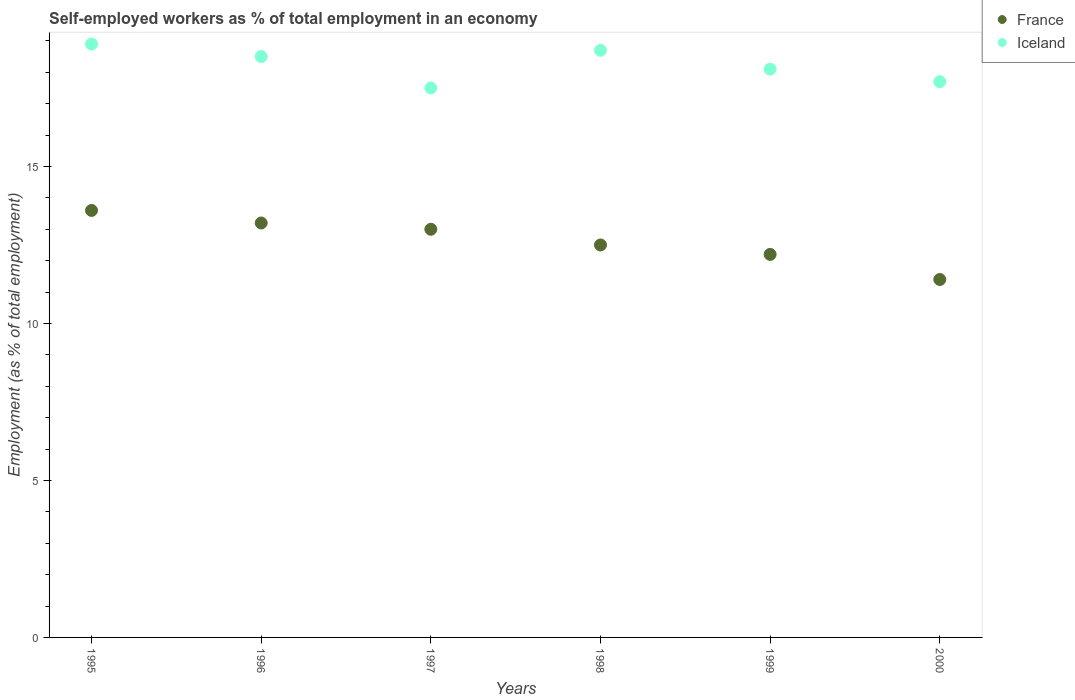Is the number of dotlines equal to the number of legend labels?
Your answer should be compact. Yes. What is the percentage of self-employed workers in Iceland in 1996?
Keep it short and to the point. 18.5. Across all years, what is the maximum percentage of self-employed workers in France?
Your answer should be compact. 13.6. In which year was the percentage of self-employed workers in France maximum?
Ensure brevity in your answer.  1995. What is the total percentage of self-employed workers in Iceland in the graph?
Offer a very short reply. 109.4. What is the difference between the percentage of self-employed workers in Iceland in 1995 and that in 1999?
Provide a short and direct response. 0.8. What is the difference between the percentage of self-employed workers in Iceland in 2000 and the percentage of self-employed workers in France in 1996?
Offer a very short reply. 4.5. What is the average percentage of self-employed workers in Iceland per year?
Your answer should be compact. 18.23. In the year 2000, what is the difference between the percentage of self-employed workers in Iceland and percentage of self-employed workers in France?
Offer a terse response. 6.3. In how many years, is the percentage of self-employed workers in France greater than 11 %?
Your response must be concise. 6. What is the ratio of the percentage of self-employed workers in Iceland in 1998 to that in 2000?
Your answer should be very brief. 1.06. Is the percentage of self-employed workers in Iceland in 1996 less than that in 2000?
Offer a very short reply. No. What is the difference between the highest and the second highest percentage of self-employed workers in Iceland?
Give a very brief answer. 0.2. What is the difference between the highest and the lowest percentage of self-employed workers in Iceland?
Your answer should be compact. 1.4. In how many years, is the percentage of self-employed workers in Iceland greater than the average percentage of self-employed workers in Iceland taken over all years?
Offer a terse response. 3. Is the percentage of self-employed workers in Iceland strictly greater than the percentage of self-employed workers in France over the years?
Your answer should be very brief. Yes. Is the percentage of self-employed workers in Iceland strictly less than the percentage of self-employed workers in France over the years?
Keep it short and to the point. No. How many dotlines are there?
Give a very brief answer. 2. How many years are there in the graph?
Provide a succinct answer. 6. What is the difference between two consecutive major ticks on the Y-axis?
Your answer should be very brief. 5. Are the values on the major ticks of Y-axis written in scientific E-notation?
Keep it short and to the point. No. Where does the legend appear in the graph?
Your answer should be compact. Top right. How many legend labels are there?
Your response must be concise. 2. How are the legend labels stacked?
Ensure brevity in your answer.  Vertical. What is the title of the graph?
Keep it short and to the point. Self-employed workers as % of total employment in an economy. What is the label or title of the Y-axis?
Keep it short and to the point. Employment (as % of total employment). What is the Employment (as % of total employment) in France in 1995?
Make the answer very short. 13.6. What is the Employment (as % of total employment) in Iceland in 1995?
Provide a succinct answer. 18.9. What is the Employment (as % of total employment) of France in 1996?
Ensure brevity in your answer.  13.2. What is the Employment (as % of total employment) of Iceland in 1996?
Provide a short and direct response. 18.5. What is the Employment (as % of total employment) of France in 1997?
Ensure brevity in your answer.  13. What is the Employment (as % of total employment) in Iceland in 1997?
Ensure brevity in your answer.  17.5. What is the Employment (as % of total employment) in France in 1998?
Provide a succinct answer. 12.5. What is the Employment (as % of total employment) of Iceland in 1998?
Your answer should be very brief. 18.7. What is the Employment (as % of total employment) of France in 1999?
Your answer should be very brief. 12.2. What is the Employment (as % of total employment) in Iceland in 1999?
Keep it short and to the point. 18.1. What is the Employment (as % of total employment) of France in 2000?
Your answer should be compact. 11.4. What is the Employment (as % of total employment) of Iceland in 2000?
Your answer should be very brief. 17.7. Across all years, what is the maximum Employment (as % of total employment) in France?
Your answer should be very brief. 13.6. Across all years, what is the maximum Employment (as % of total employment) of Iceland?
Make the answer very short. 18.9. Across all years, what is the minimum Employment (as % of total employment) in France?
Offer a very short reply. 11.4. What is the total Employment (as % of total employment) in France in the graph?
Give a very brief answer. 75.9. What is the total Employment (as % of total employment) in Iceland in the graph?
Your response must be concise. 109.4. What is the difference between the Employment (as % of total employment) of France in 1995 and that in 1996?
Provide a short and direct response. 0.4. What is the difference between the Employment (as % of total employment) of France in 1995 and that in 1997?
Your answer should be very brief. 0.6. What is the difference between the Employment (as % of total employment) in Iceland in 1995 and that in 1998?
Your answer should be compact. 0.2. What is the difference between the Employment (as % of total employment) of France in 1995 and that in 1999?
Give a very brief answer. 1.4. What is the difference between the Employment (as % of total employment) in Iceland in 1995 and that in 1999?
Your response must be concise. 0.8. What is the difference between the Employment (as % of total employment) in France in 1996 and that in 1999?
Provide a short and direct response. 1. What is the difference between the Employment (as % of total employment) of France in 1996 and that in 2000?
Your response must be concise. 1.8. What is the difference between the Employment (as % of total employment) of Iceland in 1996 and that in 2000?
Your answer should be very brief. 0.8. What is the difference between the Employment (as % of total employment) of France in 1997 and that in 1998?
Offer a terse response. 0.5. What is the difference between the Employment (as % of total employment) of Iceland in 1997 and that in 1998?
Offer a very short reply. -1.2. What is the difference between the Employment (as % of total employment) of France in 1997 and that in 1999?
Your answer should be compact. 0.8. What is the difference between the Employment (as % of total employment) of France in 1998 and that in 1999?
Offer a terse response. 0.3. What is the difference between the Employment (as % of total employment) in France in 1998 and that in 2000?
Your response must be concise. 1.1. What is the difference between the Employment (as % of total employment) of Iceland in 1999 and that in 2000?
Make the answer very short. 0.4. What is the difference between the Employment (as % of total employment) in France in 1995 and the Employment (as % of total employment) in Iceland in 1997?
Offer a very short reply. -3.9. What is the difference between the Employment (as % of total employment) in France in 1995 and the Employment (as % of total employment) in Iceland in 1999?
Offer a terse response. -4.5. What is the difference between the Employment (as % of total employment) in France in 1996 and the Employment (as % of total employment) in Iceland in 1997?
Make the answer very short. -4.3. What is the difference between the Employment (as % of total employment) of France in 1996 and the Employment (as % of total employment) of Iceland in 1999?
Offer a terse response. -4.9. What is the difference between the Employment (as % of total employment) of France in 1996 and the Employment (as % of total employment) of Iceland in 2000?
Your answer should be compact. -4.5. What is the difference between the Employment (as % of total employment) in France in 1997 and the Employment (as % of total employment) in Iceland in 1999?
Make the answer very short. -5.1. What is the difference between the Employment (as % of total employment) in France in 1997 and the Employment (as % of total employment) in Iceland in 2000?
Keep it short and to the point. -4.7. What is the difference between the Employment (as % of total employment) in France in 1998 and the Employment (as % of total employment) in Iceland in 2000?
Offer a terse response. -5.2. What is the average Employment (as % of total employment) in France per year?
Make the answer very short. 12.65. What is the average Employment (as % of total employment) in Iceland per year?
Keep it short and to the point. 18.23. In the year 1998, what is the difference between the Employment (as % of total employment) of France and Employment (as % of total employment) of Iceland?
Provide a succinct answer. -6.2. In the year 1999, what is the difference between the Employment (as % of total employment) of France and Employment (as % of total employment) of Iceland?
Your response must be concise. -5.9. In the year 2000, what is the difference between the Employment (as % of total employment) of France and Employment (as % of total employment) of Iceland?
Make the answer very short. -6.3. What is the ratio of the Employment (as % of total employment) in France in 1995 to that in 1996?
Provide a short and direct response. 1.03. What is the ratio of the Employment (as % of total employment) in Iceland in 1995 to that in 1996?
Provide a short and direct response. 1.02. What is the ratio of the Employment (as % of total employment) of France in 1995 to that in 1997?
Ensure brevity in your answer.  1.05. What is the ratio of the Employment (as % of total employment) in Iceland in 1995 to that in 1997?
Your answer should be very brief. 1.08. What is the ratio of the Employment (as % of total employment) in France in 1995 to that in 1998?
Ensure brevity in your answer.  1.09. What is the ratio of the Employment (as % of total employment) of Iceland in 1995 to that in 1998?
Provide a succinct answer. 1.01. What is the ratio of the Employment (as % of total employment) in France in 1995 to that in 1999?
Provide a succinct answer. 1.11. What is the ratio of the Employment (as % of total employment) of Iceland in 1995 to that in 1999?
Your answer should be very brief. 1.04. What is the ratio of the Employment (as % of total employment) in France in 1995 to that in 2000?
Your response must be concise. 1.19. What is the ratio of the Employment (as % of total employment) in Iceland in 1995 to that in 2000?
Your answer should be compact. 1.07. What is the ratio of the Employment (as % of total employment) in France in 1996 to that in 1997?
Offer a terse response. 1.02. What is the ratio of the Employment (as % of total employment) in Iceland in 1996 to that in 1997?
Keep it short and to the point. 1.06. What is the ratio of the Employment (as % of total employment) of France in 1996 to that in 1998?
Ensure brevity in your answer.  1.06. What is the ratio of the Employment (as % of total employment) of Iceland in 1996 to that in 1998?
Your answer should be very brief. 0.99. What is the ratio of the Employment (as % of total employment) of France in 1996 to that in 1999?
Offer a terse response. 1.08. What is the ratio of the Employment (as % of total employment) of Iceland in 1996 to that in 1999?
Make the answer very short. 1.02. What is the ratio of the Employment (as % of total employment) of France in 1996 to that in 2000?
Keep it short and to the point. 1.16. What is the ratio of the Employment (as % of total employment) in Iceland in 1996 to that in 2000?
Your response must be concise. 1.05. What is the ratio of the Employment (as % of total employment) of Iceland in 1997 to that in 1998?
Provide a succinct answer. 0.94. What is the ratio of the Employment (as % of total employment) in France in 1997 to that in 1999?
Give a very brief answer. 1.07. What is the ratio of the Employment (as % of total employment) of Iceland in 1997 to that in 1999?
Your response must be concise. 0.97. What is the ratio of the Employment (as % of total employment) in France in 1997 to that in 2000?
Your answer should be compact. 1.14. What is the ratio of the Employment (as % of total employment) in Iceland in 1997 to that in 2000?
Keep it short and to the point. 0.99. What is the ratio of the Employment (as % of total employment) of France in 1998 to that in 1999?
Offer a very short reply. 1.02. What is the ratio of the Employment (as % of total employment) of Iceland in 1998 to that in 1999?
Provide a short and direct response. 1.03. What is the ratio of the Employment (as % of total employment) of France in 1998 to that in 2000?
Give a very brief answer. 1.1. What is the ratio of the Employment (as % of total employment) of Iceland in 1998 to that in 2000?
Keep it short and to the point. 1.06. What is the ratio of the Employment (as % of total employment) of France in 1999 to that in 2000?
Your response must be concise. 1.07. What is the ratio of the Employment (as % of total employment) in Iceland in 1999 to that in 2000?
Ensure brevity in your answer.  1.02. What is the difference between the highest and the second highest Employment (as % of total employment) of France?
Give a very brief answer. 0.4. What is the difference between the highest and the second highest Employment (as % of total employment) in Iceland?
Provide a succinct answer. 0.2. 